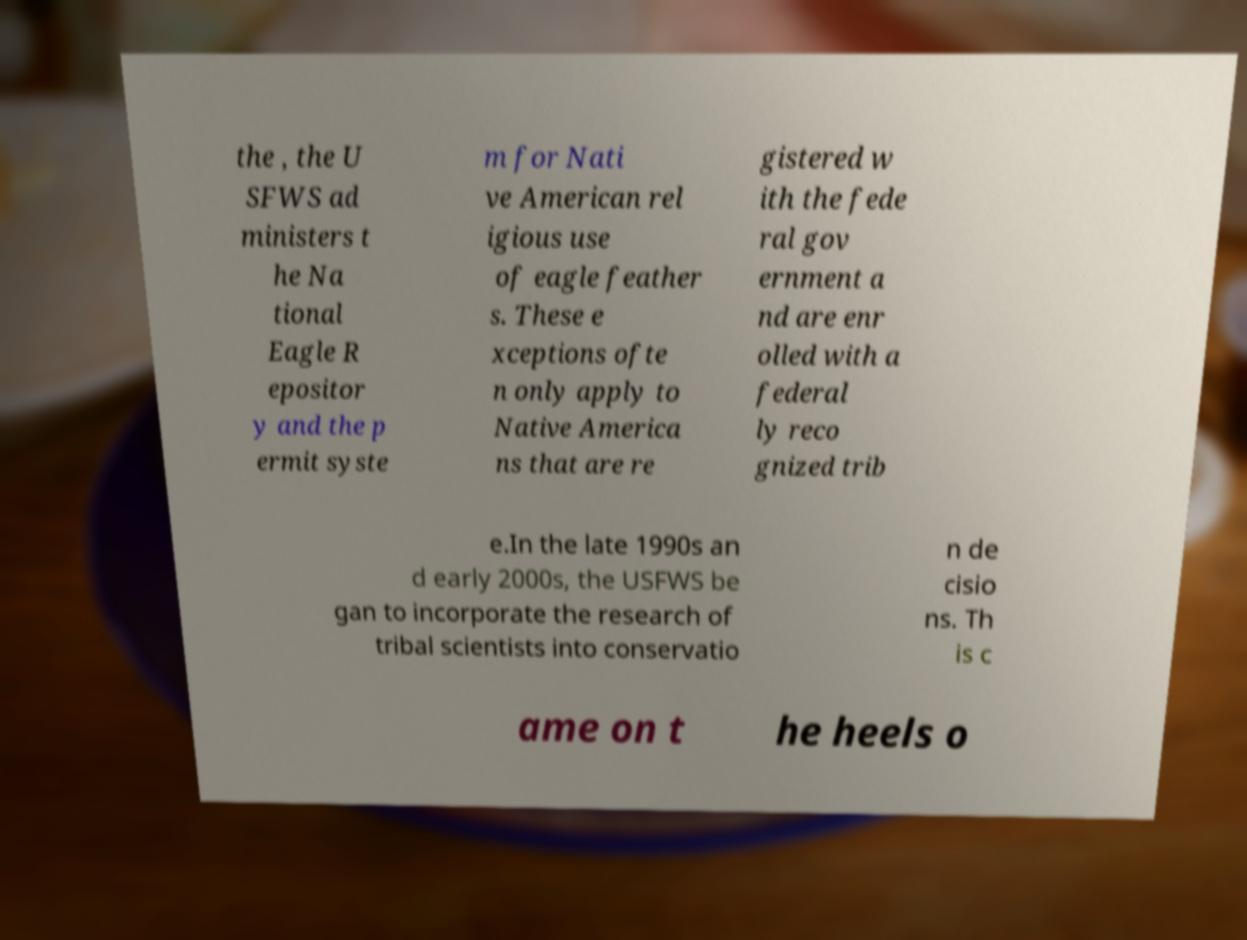Please identify and transcribe the text found in this image. the , the U SFWS ad ministers t he Na tional Eagle R epositor y and the p ermit syste m for Nati ve American rel igious use of eagle feather s. These e xceptions ofte n only apply to Native America ns that are re gistered w ith the fede ral gov ernment a nd are enr olled with a federal ly reco gnized trib e.In the late 1990s an d early 2000s, the USFWS be gan to incorporate the research of tribal scientists into conservatio n de cisio ns. Th is c ame on t he heels o 